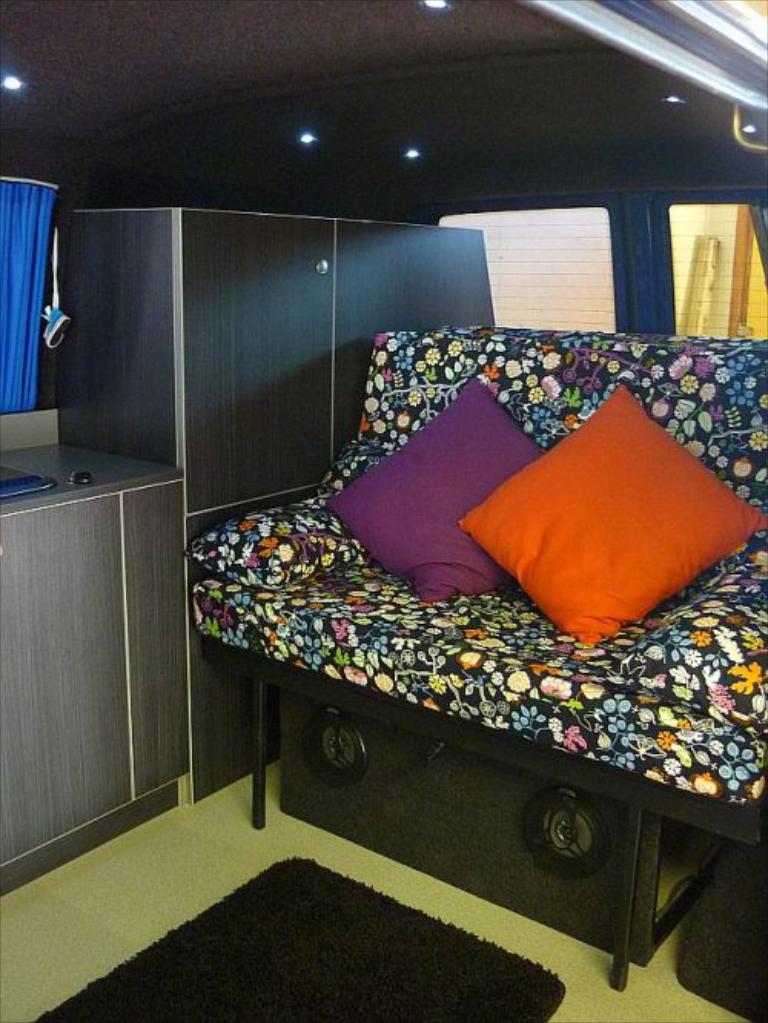Can you describe this image briefly? In this image we can see sofa, pillows, speakers, cupboards, curtain and windows. 